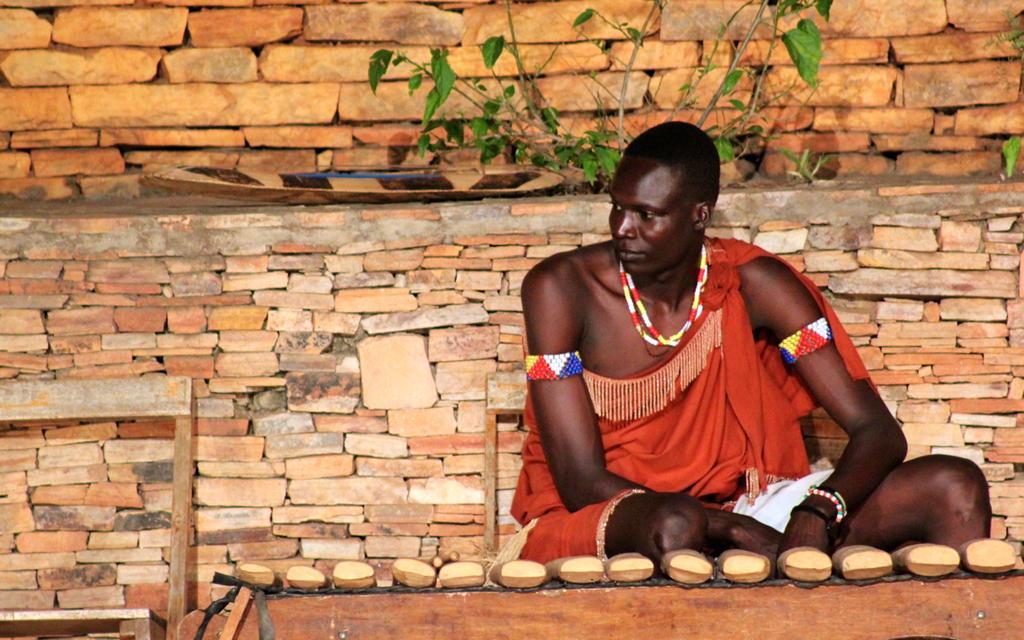How would you summarize this image in a sentence or two? In this picture, we see a man in the red costume is sitting on the chair. In front of him, we see the wooden sticks. These sticks might be the sandalwoods. On the left side, we see a wooden chair or a bench. In the background, we see a wall which is made up of stones. We even see a plant or a tree. 